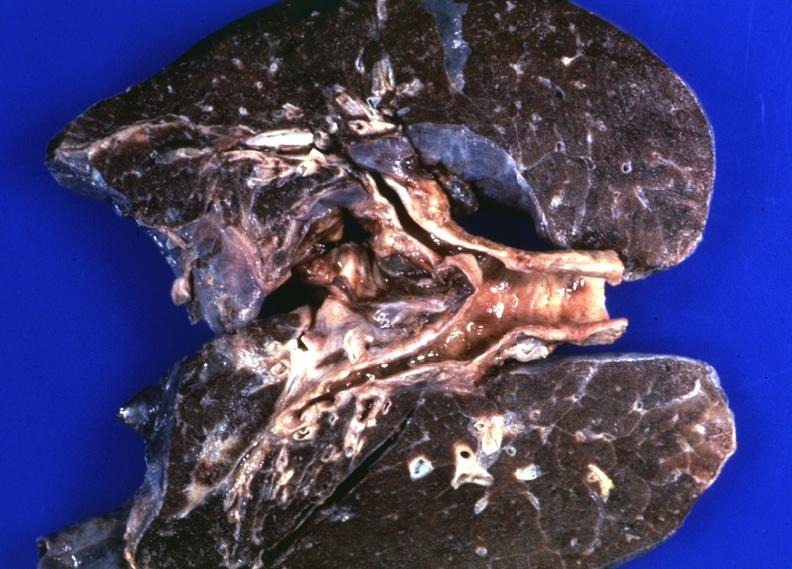what is present?
Answer the question using a single word or phrase. Respiratory 